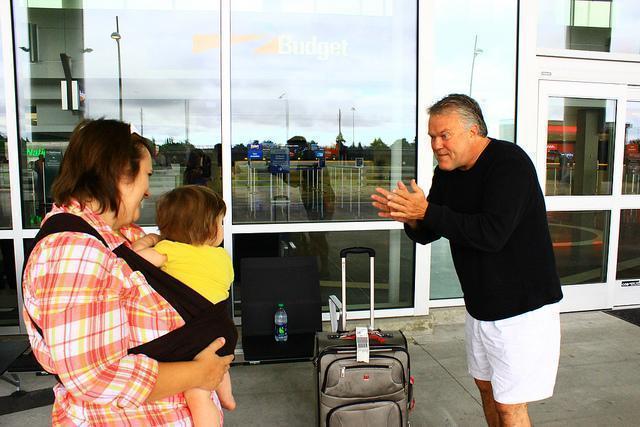What is the woman carrying?
Choose the right answer from the provided options to respond to the question.
Options: Baby, egg, basket, crown. Baby. 